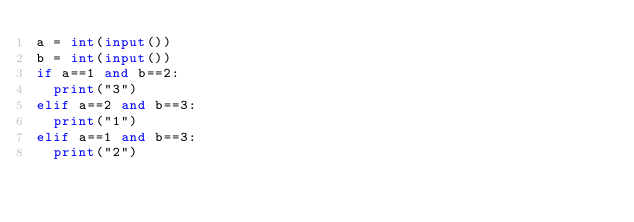<code> <loc_0><loc_0><loc_500><loc_500><_Python_>a = int(input())
b = int(input())
if a==1 and b==2:
  print("3")
elif a==2 and b==3:
  print("1")
elif a==1 and b==3:
  print("2")</code> 